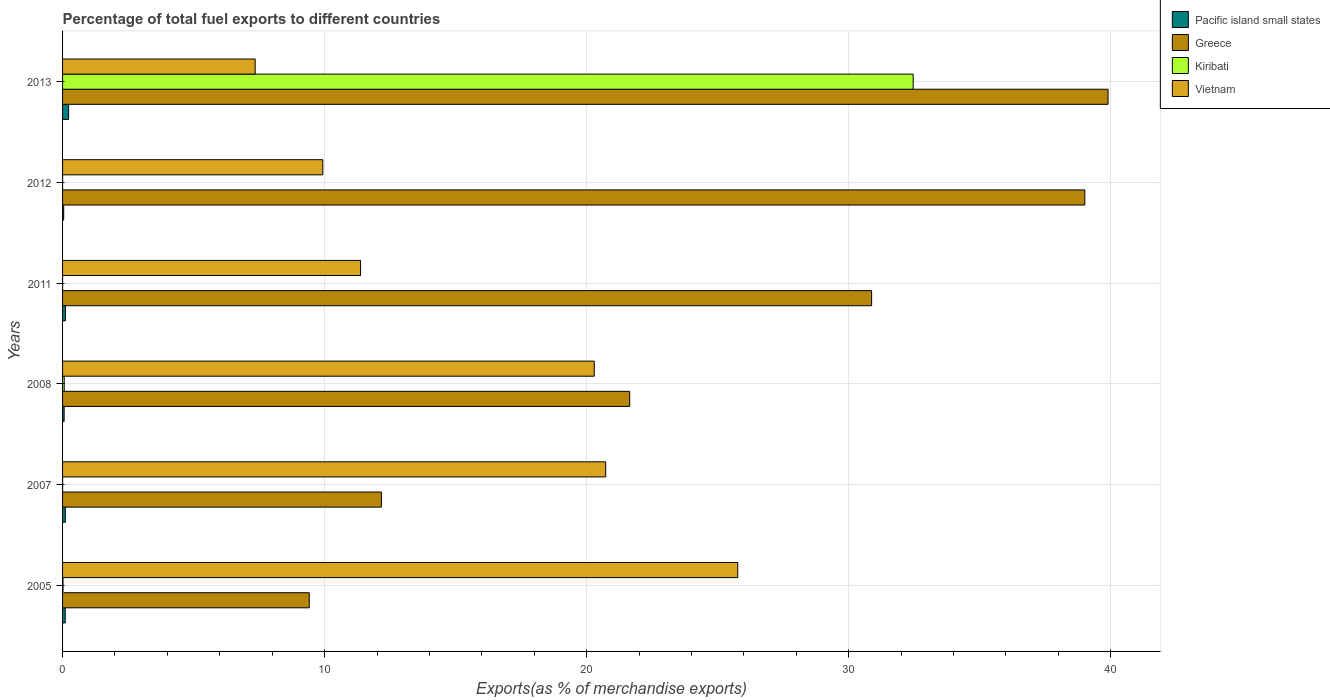Are the number of bars on each tick of the Y-axis equal?
Ensure brevity in your answer.  Yes. In how many cases, is the number of bars for a given year not equal to the number of legend labels?
Make the answer very short. 0. What is the percentage of exports to different countries in Greece in 2008?
Provide a short and direct response. 21.64. Across all years, what is the maximum percentage of exports to different countries in Vietnam?
Provide a succinct answer. 25.77. Across all years, what is the minimum percentage of exports to different countries in Kiribati?
Offer a terse response. 0. What is the total percentage of exports to different countries in Vietnam in the graph?
Provide a succinct answer. 95.43. What is the difference between the percentage of exports to different countries in Pacific island small states in 2005 and that in 2011?
Offer a very short reply. -0.01. What is the difference between the percentage of exports to different countries in Pacific island small states in 2011 and the percentage of exports to different countries in Greece in 2012?
Your answer should be very brief. -38.9. What is the average percentage of exports to different countries in Pacific island small states per year?
Keep it short and to the point. 0.11. In the year 2007, what is the difference between the percentage of exports to different countries in Greece and percentage of exports to different countries in Pacific island small states?
Keep it short and to the point. 12.06. In how many years, is the percentage of exports to different countries in Kiribati greater than 28 %?
Offer a very short reply. 1. What is the ratio of the percentage of exports to different countries in Vietnam in 2005 to that in 2011?
Your answer should be compact. 2.27. What is the difference between the highest and the second highest percentage of exports to different countries in Pacific island small states?
Your response must be concise. 0.12. What is the difference between the highest and the lowest percentage of exports to different countries in Vietnam?
Provide a short and direct response. 18.42. Is the sum of the percentage of exports to different countries in Greece in 2008 and 2013 greater than the maximum percentage of exports to different countries in Vietnam across all years?
Your answer should be very brief. Yes. What does the 4th bar from the top in 2012 represents?
Provide a short and direct response. Pacific island small states. What does the 4th bar from the bottom in 2013 represents?
Make the answer very short. Vietnam. Is it the case that in every year, the sum of the percentage of exports to different countries in Pacific island small states and percentage of exports to different countries in Vietnam is greater than the percentage of exports to different countries in Kiribati?
Ensure brevity in your answer.  No. How many bars are there?
Offer a terse response. 24. What is the difference between two consecutive major ticks on the X-axis?
Your answer should be very brief. 10. Does the graph contain any zero values?
Provide a short and direct response. No. Does the graph contain grids?
Your answer should be very brief. Yes. Where does the legend appear in the graph?
Provide a succinct answer. Top right. How many legend labels are there?
Provide a short and direct response. 4. How are the legend labels stacked?
Your response must be concise. Vertical. What is the title of the graph?
Your response must be concise. Percentage of total fuel exports to different countries. Does "Estonia" appear as one of the legend labels in the graph?
Make the answer very short. No. What is the label or title of the X-axis?
Offer a very short reply. Exports(as % of merchandise exports). What is the label or title of the Y-axis?
Offer a terse response. Years. What is the Exports(as % of merchandise exports) of Pacific island small states in 2005?
Keep it short and to the point. 0.1. What is the Exports(as % of merchandise exports) in Greece in 2005?
Provide a succinct answer. 9.41. What is the Exports(as % of merchandise exports) of Kiribati in 2005?
Your answer should be compact. 0.02. What is the Exports(as % of merchandise exports) in Vietnam in 2005?
Offer a terse response. 25.77. What is the Exports(as % of merchandise exports) of Pacific island small states in 2007?
Provide a succinct answer. 0.1. What is the Exports(as % of merchandise exports) of Greece in 2007?
Provide a succinct answer. 12.17. What is the Exports(as % of merchandise exports) in Kiribati in 2007?
Offer a terse response. 0. What is the Exports(as % of merchandise exports) in Vietnam in 2007?
Your answer should be compact. 20.73. What is the Exports(as % of merchandise exports) of Pacific island small states in 2008?
Your answer should be very brief. 0.06. What is the Exports(as % of merchandise exports) in Greece in 2008?
Provide a short and direct response. 21.64. What is the Exports(as % of merchandise exports) of Kiribati in 2008?
Your answer should be compact. 0.06. What is the Exports(as % of merchandise exports) in Vietnam in 2008?
Offer a very short reply. 20.29. What is the Exports(as % of merchandise exports) of Pacific island small states in 2011?
Make the answer very short. 0.11. What is the Exports(as % of merchandise exports) in Greece in 2011?
Provide a succinct answer. 30.87. What is the Exports(as % of merchandise exports) of Kiribati in 2011?
Keep it short and to the point. 0. What is the Exports(as % of merchandise exports) of Vietnam in 2011?
Your response must be concise. 11.37. What is the Exports(as % of merchandise exports) of Pacific island small states in 2012?
Keep it short and to the point. 0.04. What is the Exports(as % of merchandise exports) in Greece in 2012?
Offer a terse response. 39.01. What is the Exports(as % of merchandise exports) of Kiribati in 2012?
Provide a succinct answer. 0. What is the Exports(as % of merchandise exports) of Vietnam in 2012?
Provide a short and direct response. 9.93. What is the Exports(as % of merchandise exports) in Pacific island small states in 2013?
Provide a short and direct response. 0.23. What is the Exports(as % of merchandise exports) in Greece in 2013?
Keep it short and to the point. 39.9. What is the Exports(as % of merchandise exports) in Kiribati in 2013?
Ensure brevity in your answer.  32.46. What is the Exports(as % of merchandise exports) in Vietnam in 2013?
Provide a succinct answer. 7.35. Across all years, what is the maximum Exports(as % of merchandise exports) of Pacific island small states?
Make the answer very short. 0.23. Across all years, what is the maximum Exports(as % of merchandise exports) of Greece?
Provide a succinct answer. 39.9. Across all years, what is the maximum Exports(as % of merchandise exports) of Kiribati?
Make the answer very short. 32.46. Across all years, what is the maximum Exports(as % of merchandise exports) of Vietnam?
Your answer should be compact. 25.77. Across all years, what is the minimum Exports(as % of merchandise exports) of Pacific island small states?
Ensure brevity in your answer.  0.04. Across all years, what is the minimum Exports(as % of merchandise exports) in Greece?
Make the answer very short. 9.41. Across all years, what is the minimum Exports(as % of merchandise exports) in Kiribati?
Give a very brief answer. 0. Across all years, what is the minimum Exports(as % of merchandise exports) of Vietnam?
Your answer should be very brief. 7.35. What is the total Exports(as % of merchandise exports) in Pacific island small states in the graph?
Offer a very short reply. 0.65. What is the total Exports(as % of merchandise exports) in Greece in the graph?
Give a very brief answer. 153. What is the total Exports(as % of merchandise exports) in Kiribati in the graph?
Your response must be concise. 32.54. What is the total Exports(as % of merchandise exports) in Vietnam in the graph?
Offer a very short reply. 95.43. What is the difference between the Exports(as % of merchandise exports) in Pacific island small states in 2005 and that in 2007?
Make the answer very short. -0. What is the difference between the Exports(as % of merchandise exports) in Greece in 2005 and that in 2007?
Provide a succinct answer. -2.75. What is the difference between the Exports(as % of merchandise exports) in Kiribati in 2005 and that in 2007?
Your answer should be very brief. 0.02. What is the difference between the Exports(as % of merchandise exports) of Vietnam in 2005 and that in 2007?
Make the answer very short. 5.04. What is the difference between the Exports(as % of merchandise exports) of Pacific island small states in 2005 and that in 2008?
Make the answer very short. 0.04. What is the difference between the Exports(as % of merchandise exports) of Greece in 2005 and that in 2008?
Your answer should be compact. -12.23. What is the difference between the Exports(as % of merchandise exports) of Kiribati in 2005 and that in 2008?
Ensure brevity in your answer.  -0.05. What is the difference between the Exports(as % of merchandise exports) of Vietnam in 2005 and that in 2008?
Make the answer very short. 5.48. What is the difference between the Exports(as % of merchandise exports) of Pacific island small states in 2005 and that in 2011?
Give a very brief answer. -0.01. What is the difference between the Exports(as % of merchandise exports) in Greece in 2005 and that in 2011?
Keep it short and to the point. -21.46. What is the difference between the Exports(as % of merchandise exports) of Kiribati in 2005 and that in 2011?
Your answer should be very brief. 0.02. What is the difference between the Exports(as % of merchandise exports) in Vietnam in 2005 and that in 2011?
Your answer should be very brief. 14.39. What is the difference between the Exports(as % of merchandise exports) of Pacific island small states in 2005 and that in 2012?
Make the answer very short. 0.06. What is the difference between the Exports(as % of merchandise exports) in Greece in 2005 and that in 2012?
Ensure brevity in your answer.  -29.59. What is the difference between the Exports(as % of merchandise exports) in Kiribati in 2005 and that in 2012?
Make the answer very short. 0.02. What is the difference between the Exports(as % of merchandise exports) in Vietnam in 2005 and that in 2012?
Offer a very short reply. 15.84. What is the difference between the Exports(as % of merchandise exports) in Pacific island small states in 2005 and that in 2013?
Provide a short and direct response. -0.13. What is the difference between the Exports(as % of merchandise exports) of Greece in 2005 and that in 2013?
Keep it short and to the point. -30.48. What is the difference between the Exports(as % of merchandise exports) of Kiribati in 2005 and that in 2013?
Provide a short and direct response. -32.44. What is the difference between the Exports(as % of merchandise exports) in Vietnam in 2005 and that in 2013?
Keep it short and to the point. 18.42. What is the difference between the Exports(as % of merchandise exports) in Pacific island small states in 2007 and that in 2008?
Provide a succinct answer. 0.04. What is the difference between the Exports(as % of merchandise exports) in Greece in 2007 and that in 2008?
Make the answer very short. -9.47. What is the difference between the Exports(as % of merchandise exports) in Kiribati in 2007 and that in 2008?
Provide a short and direct response. -0.06. What is the difference between the Exports(as % of merchandise exports) of Vietnam in 2007 and that in 2008?
Your answer should be compact. 0.44. What is the difference between the Exports(as % of merchandise exports) in Pacific island small states in 2007 and that in 2011?
Provide a succinct answer. -0.01. What is the difference between the Exports(as % of merchandise exports) of Greece in 2007 and that in 2011?
Ensure brevity in your answer.  -18.71. What is the difference between the Exports(as % of merchandise exports) in Kiribati in 2007 and that in 2011?
Offer a terse response. 0. What is the difference between the Exports(as % of merchandise exports) in Vietnam in 2007 and that in 2011?
Provide a succinct answer. 9.35. What is the difference between the Exports(as % of merchandise exports) in Pacific island small states in 2007 and that in 2012?
Make the answer very short. 0.06. What is the difference between the Exports(as % of merchandise exports) in Greece in 2007 and that in 2012?
Offer a terse response. -26.84. What is the difference between the Exports(as % of merchandise exports) of Vietnam in 2007 and that in 2012?
Your answer should be compact. 10.8. What is the difference between the Exports(as % of merchandise exports) of Pacific island small states in 2007 and that in 2013?
Offer a very short reply. -0.13. What is the difference between the Exports(as % of merchandise exports) in Greece in 2007 and that in 2013?
Your answer should be very brief. -27.73. What is the difference between the Exports(as % of merchandise exports) in Kiribati in 2007 and that in 2013?
Give a very brief answer. -32.46. What is the difference between the Exports(as % of merchandise exports) of Vietnam in 2007 and that in 2013?
Give a very brief answer. 13.38. What is the difference between the Exports(as % of merchandise exports) in Pacific island small states in 2008 and that in 2011?
Your response must be concise. -0.05. What is the difference between the Exports(as % of merchandise exports) of Greece in 2008 and that in 2011?
Keep it short and to the point. -9.23. What is the difference between the Exports(as % of merchandise exports) of Kiribati in 2008 and that in 2011?
Your answer should be very brief. 0.06. What is the difference between the Exports(as % of merchandise exports) of Vietnam in 2008 and that in 2011?
Offer a very short reply. 8.92. What is the difference between the Exports(as % of merchandise exports) of Pacific island small states in 2008 and that in 2012?
Ensure brevity in your answer.  0.02. What is the difference between the Exports(as % of merchandise exports) of Greece in 2008 and that in 2012?
Offer a terse response. -17.37. What is the difference between the Exports(as % of merchandise exports) of Kiribati in 2008 and that in 2012?
Your response must be concise. 0.06. What is the difference between the Exports(as % of merchandise exports) in Vietnam in 2008 and that in 2012?
Your response must be concise. 10.36. What is the difference between the Exports(as % of merchandise exports) in Pacific island small states in 2008 and that in 2013?
Your answer should be very brief. -0.17. What is the difference between the Exports(as % of merchandise exports) of Greece in 2008 and that in 2013?
Provide a succinct answer. -18.25. What is the difference between the Exports(as % of merchandise exports) in Kiribati in 2008 and that in 2013?
Provide a short and direct response. -32.4. What is the difference between the Exports(as % of merchandise exports) of Vietnam in 2008 and that in 2013?
Your answer should be compact. 12.94. What is the difference between the Exports(as % of merchandise exports) in Pacific island small states in 2011 and that in 2012?
Keep it short and to the point. 0.07. What is the difference between the Exports(as % of merchandise exports) in Greece in 2011 and that in 2012?
Offer a very short reply. -8.13. What is the difference between the Exports(as % of merchandise exports) in Kiribati in 2011 and that in 2012?
Keep it short and to the point. -0. What is the difference between the Exports(as % of merchandise exports) in Vietnam in 2011 and that in 2012?
Give a very brief answer. 1.44. What is the difference between the Exports(as % of merchandise exports) of Pacific island small states in 2011 and that in 2013?
Give a very brief answer. -0.12. What is the difference between the Exports(as % of merchandise exports) of Greece in 2011 and that in 2013?
Your answer should be compact. -9.02. What is the difference between the Exports(as % of merchandise exports) in Kiribati in 2011 and that in 2013?
Offer a very short reply. -32.46. What is the difference between the Exports(as % of merchandise exports) in Vietnam in 2011 and that in 2013?
Your response must be concise. 4.02. What is the difference between the Exports(as % of merchandise exports) of Pacific island small states in 2012 and that in 2013?
Your answer should be very brief. -0.19. What is the difference between the Exports(as % of merchandise exports) in Greece in 2012 and that in 2013?
Your response must be concise. -0.89. What is the difference between the Exports(as % of merchandise exports) of Kiribati in 2012 and that in 2013?
Your response must be concise. -32.46. What is the difference between the Exports(as % of merchandise exports) of Vietnam in 2012 and that in 2013?
Make the answer very short. 2.58. What is the difference between the Exports(as % of merchandise exports) in Pacific island small states in 2005 and the Exports(as % of merchandise exports) in Greece in 2007?
Ensure brevity in your answer.  -12.06. What is the difference between the Exports(as % of merchandise exports) in Pacific island small states in 2005 and the Exports(as % of merchandise exports) in Kiribati in 2007?
Make the answer very short. 0.1. What is the difference between the Exports(as % of merchandise exports) in Pacific island small states in 2005 and the Exports(as % of merchandise exports) in Vietnam in 2007?
Ensure brevity in your answer.  -20.62. What is the difference between the Exports(as % of merchandise exports) in Greece in 2005 and the Exports(as % of merchandise exports) in Kiribati in 2007?
Ensure brevity in your answer.  9.41. What is the difference between the Exports(as % of merchandise exports) of Greece in 2005 and the Exports(as % of merchandise exports) of Vietnam in 2007?
Offer a very short reply. -11.31. What is the difference between the Exports(as % of merchandise exports) in Kiribati in 2005 and the Exports(as % of merchandise exports) in Vietnam in 2007?
Offer a very short reply. -20.71. What is the difference between the Exports(as % of merchandise exports) of Pacific island small states in 2005 and the Exports(as % of merchandise exports) of Greece in 2008?
Ensure brevity in your answer.  -21.54. What is the difference between the Exports(as % of merchandise exports) of Pacific island small states in 2005 and the Exports(as % of merchandise exports) of Kiribati in 2008?
Provide a short and direct response. 0.04. What is the difference between the Exports(as % of merchandise exports) of Pacific island small states in 2005 and the Exports(as % of merchandise exports) of Vietnam in 2008?
Provide a short and direct response. -20.19. What is the difference between the Exports(as % of merchandise exports) of Greece in 2005 and the Exports(as % of merchandise exports) of Kiribati in 2008?
Make the answer very short. 9.35. What is the difference between the Exports(as % of merchandise exports) of Greece in 2005 and the Exports(as % of merchandise exports) of Vietnam in 2008?
Make the answer very short. -10.88. What is the difference between the Exports(as % of merchandise exports) of Kiribati in 2005 and the Exports(as % of merchandise exports) of Vietnam in 2008?
Your response must be concise. -20.27. What is the difference between the Exports(as % of merchandise exports) in Pacific island small states in 2005 and the Exports(as % of merchandise exports) in Greece in 2011?
Provide a short and direct response. -30.77. What is the difference between the Exports(as % of merchandise exports) of Pacific island small states in 2005 and the Exports(as % of merchandise exports) of Kiribati in 2011?
Your response must be concise. 0.1. What is the difference between the Exports(as % of merchandise exports) in Pacific island small states in 2005 and the Exports(as % of merchandise exports) in Vietnam in 2011?
Ensure brevity in your answer.  -11.27. What is the difference between the Exports(as % of merchandise exports) of Greece in 2005 and the Exports(as % of merchandise exports) of Kiribati in 2011?
Give a very brief answer. 9.41. What is the difference between the Exports(as % of merchandise exports) in Greece in 2005 and the Exports(as % of merchandise exports) in Vietnam in 2011?
Your answer should be compact. -1.96. What is the difference between the Exports(as % of merchandise exports) of Kiribati in 2005 and the Exports(as % of merchandise exports) of Vietnam in 2011?
Your answer should be very brief. -11.36. What is the difference between the Exports(as % of merchandise exports) of Pacific island small states in 2005 and the Exports(as % of merchandise exports) of Greece in 2012?
Give a very brief answer. -38.91. What is the difference between the Exports(as % of merchandise exports) of Pacific island small states in 2005 and the Exports(as % of merchandise exports) of Kiribati in 2012?
Offer a very short reply. 0.1. What is the difference between the Exports(as % of merchandise exports) of Pacific island small states in 2005 and the Exports(as % of merchandise exports) of Vietnam in 2012?
Offer a very short reply. -9.83. What is the difference between the Exports(as % of merchandise exports) in Greece in 2005 and the Exports(as % of merchandise exports) in Kiribati in 2012?
Provide a short and direct response. 9.41. What is the difference between the Exports(as % of merchandise exports) in Greece in 2005 and the Exports(as % of merchandise exports) in Vietnam in 2012?
Make the answer very short. -0.52. What is the difference between the Exports(as % of merchandise exports) in Kiribati in 2005 and the Exports(as % of merchandise exports) in Vietnam in 2012?
Offer a terse response. -9.91. What is the difference between the Exports(as % of merchandise exports) of Pacific island small states in 2005 and the Exports(as % of merchandise exports) of Greece in 2013?
Provide a short and direct response. -39.79. What is the difference between the Exports(as % of merchandise exports) in Pacific island small states in 2005 and the Exports(as % of merchandise exports) in Kiribati in 2013?
Make the answer very short. -32.36. What is the difference between the Exports(as % of merchandise exports) in Pacific island small states in 2005 and the Exports(as % of merchandise exports) in Vietnam in 2013?
Provide a succinct answer. -7.25. What is the difference between the Exports(as % of merchandise exports) of Greece in 2005 and the Exports(as % of merchandise exports) of Kiribati in 2013?
Ensure brevity in your answer.  -23.05. What is the difference between the Exports(as % of merchandise exports) in Greece in 2005 and the Exports(as % of merchandise exports) in Vietnam in 2013?
Make the answer very short. 2.06. What is the difference between the Exports(as % of merchandise exports) in Kiribati in 2005 and the Exports(as % of merchandise exports) in Vietnam in 2013?
Your answer should be compact. -7.33. What is the difference between the Exports(as % of merchandise exports) in Pacific island small states in 2007 and the Exports(as % of merchandise exports) in Greece in 2008?
Your answer should be compact. -21.54. What is the difference between the Exports(as % of merchandise exports) in Pacific island small states in 2007 and the Exports(as % of merchandise exports) in Kiribati in 2008?
Provide a succinct answer. 0.04. What is the difference between the Exports(as % of merchandise exports) of Pacific island small states in 2007 and the Exports(as % of merchandise exports) of Vietnam in 2008?
Offer a terse response. -20.19. What is the difference between the Exports(as % of merchandise exports) of Greece in 2007 and the Exports(as % of merchandise exports) of Kiribati in 2008?
Your answer should be compact. 12.1. What is the difference between the Exports(as % of merchandise exports) in Greece in 2007 and the Exports(as % of merchandise exports) in Vietnam in 2008?
Your response must be concise. -8.12. What is the difference between the Exports(as % of merchandise exports) in Kiribati in 2007 and the Exports(as % of merchandise exports) in Vietnam in 2008?
Keep it short and to the point. -20.29. What is the difference between the Exports(as % of merchandise exports) in Pacific island small states in 2007 and the Exports(as % of merchandise exports) in Greece in 2011?
Your answer should be compact. -30.77. What is the difference between the Exports(as % of merchandise exports) in Pacific island small states in 2007 and the Exports(as % of merchandise exports) in Kiribati in 2011?
Offer a terse response. 0.1. What is the difference between the Exports(as % of merchandise exports) of Pacific island small states in 2007 and the Exports(as % of merchandise exports) of Vietnam in 2011?
Your response must be concise. -11.27. What is the difference between the Exports(as % of merchandise exports) of Greece in 2007 and the Exports(as % of merchandise exports) of Kiribati in 2011?
Provide a succinct answer. 12.17. What is the difference between the Exports(as % of merchandise exports) of Greece in 2007 and the Exports(as % of merchandise exports) of Vietnam in 2011?
Offer a very short reply. 0.8. What is the difference between the Exports(as % of merchandise exports) in Kiribati in 2007 and the Exports(as % of merchandise exports) in Vietnam in 2011?
Provide a short and direct response. -11.37. What is the difference between the Exports(as % of merchandise exports) in Pacific island small states in 2007 and the Exports(as % of merchandise exports) in Greece in 2012?
Offer a very short reply. -38.9. What is the difference between the Exports(as % of merchandise exports) of Pacific island small states in 2007 and the Exports(as % of merchandise exports) of Kiribati in 2012?
Provide a succinct answer. 0.1. What is the difference between the Exports(as % of merchandise exports) in Pacific island small states in 2007 and the Exports(as % of merchandise exports) in Vietnam in 2012?
Provide a succinct answer. -9.83. What is the difference between the Exports(as % of merchandise exports) of Greece in 2007 and the Exports(as % of merchandise exports) of Kiribati in 2012?
Your answer should be very brief. 12.17. What is the difference between the Exports(as % of merchandise exports) in Greece in 2007 and the Exports(as % of merchandise exports) in Vietnam in 2012?
Provide a succinct answer. 2.24. What is the difference between the Exports(as % of merchandise exports) in Kiribati in 2007 and the Exports(as % of merchandise exports) in Vietnam in 2012?
Ensure brevity in your answer.  -9.93. What is the difference between the Exports(as % of merchandise exports) in Pacific island small states in 2007 and the Exports(as % of merchandise exports) in Greece in 2013?
Ensure brevity in your answer.  -39.79. What is the difference between the Exports(as % of merchandise exports) in Pacific island small states in 2007 and the Exports(as % of merchandise exports) in Kiribati in 2013?
Give a very brief answer. -32.35. What is the difference between the Exports(as % of merchandise exports) in Pacific island small states in 2007 and the Exports(as % of merchandise exports) in Vietnam in 2013?
Make the answer very short. -7.25. What is the difference between the Exports(as % of merchandise exports) in Greece in 2007 and the Exports(as % of merchandise exports) in Kiribati in 2013?
Your response must be concise. -20.29. What is the difference between the Exports(as % of merchandise exports) of Greece in 2007 and the Exports(as % of merchandise exports) of Vietnam in 2013?
Provide a short and direct response. 4.82. What is the difference between the Exports(as % of merchandise exports) in Kiribati in 2007 and the Exports(as % of merchandise exports) in Vietnam in 2013?
Ensure brevity in your answer.  -7.35. What is the difference between the Exports(as % of merchandise exports) of Pacific island small states in 2008 and the Exports(as % of merchandise exports) of Greece in 2011?
Your answer should be very brief. -30.81. What is the difference between the Exports(as % of merchandise exports) in Pacific island small states in 2008 and the Exports(as % of merchandise exports) in Kiribati in 2011?
Provide a succinct answer. 0.06. What is the difference between the Exports(as % of merchandise exports) in Pacific island small states in 2008 and the Exports(as % of merchandise exports) in Vietnam in 2011?
Provide a succinct answer. -11.31. What is the difference between the Exports(as % of merchandise exports) of Greece in 2008 and the Exports(as % of merchandise exports) of Kiribati in 2011?
Keep it short and to the point. 21.64. What is the difference between the Exports(as % of merchandise exports) of Greece in 2008 and the Exports(as % of merchandise exports) of Vietnam in 2011?
Offer a very short reply. 10.27. What is the difference between the Exports(as % of merchandise exports) of Kiribati in 2008 and the Exports(as % of merchandise exports) of Vietnam in 2011?
Provide a succinct answer. -11.31. What is the difference between the Exports(as % of merchandise exports) of Pacific island small states in 2008 and the Exports(as % of merchandise exports) of Greece in 2012?
Offer a very short reply. -38.95. What is the difference between the Exports(as % of merchandise exports) in Pacific island small states in 2008 and the Exports(as % of merchandise exports) in Kiribati in 2012?
Your response must be concise. 0.06. What is the difference between the Exports(as % of merchandise exports) in Pacific island small states in 2008 and the Exports(as % of merchandise exports) in Vietnam in 2012?
Ensure brevity in your answer.  -9.87. What is the difference between the Exports(as % of merchandise exports) in Greece in 2008 and the Exports(as % of merchandise exports) in Kiribati in 2012?
Your response must be concise. 21.64. What is the difference between the Exports(as % of merchandise exports) of Greece in 2008 and the Exports(as % of merchandise exports) of Vietnam in 2012?
Offer a terse response. 11.71. What is the difference between the Exports(as % of merchandise exports) in Kiribati in 2008 and the Exports(as % of merchandise exports) in Vietnam in 2012?
Keep it short and to the point. -9.87. What is the difference between the Exports(as % of merchandise exports) of Pacific island small states in 2008 and the Exports(as % of merchandise exports) of Greece in 2013?
Provide a succinct answer. -39.84. What is the difference between the Exports(as % of merchandise exports) in Pacific island small states in 2008 and the Exports(as % of merchandise exports) in Kiribati in 2013?
Give a very brief answer. -32.4. What is the difference between the Exports(as % of merchandise exports) in Pacific island small states in 2008 and the Exports(as % of merchandise exports) in Vietnam in 2013?
Your answer should be compact. -7.29. What is the difference between the Exports(as % of merchandise exports) in Greece in 2008 and the Exports(as % of merchandise exports) in Kiribati in 2013?
Ensure brevity in your answer.  -10.82. What is the difference between the Exports(as % of merchandise exports) of Greece in 2008 and the Exports(as % of merchandise exports) of Vietnam in 2013?
Offer a very short reply. 14.29. What is the difference between the Exports(as % of merchandise exports) of Kiribati in 2008 and the Exports(as % of merchandise exports) of Vietnam in 2013?
Offer a terse response. -7.29. What is the difference between the Exports(as % of merchandise exports) of Pacific island small states in 2011 and the Exports(as % of merchandise exports) of Greece in 2012?
Make the answer very short. -38.9. What is the difference between the Exports(as % of merchandise exports) of Pacific island small states in 2011 and the Exports(as % of merchandise exports) of Kiribati in 2012?
Your response must be concise. 0.11. What is the difference between the Exports(as % of merchandise exports) in Pacific island small states in 2011 and the Exports(as % of merchandise exports) in Vietnam in 2012?
Keep it short and to the point. -9.82. What is the difference between the Exports(as % of merchandise exports) in Greece in 2011 and the Exports(as % of merchandise exports) in Kiribati in 2012?
Make the answer very short. 30.87. What is the difference between the Exports(as % of merchandise exports) in Greece in 2011 and the Exports(as % of merchandise exports) in Vietnam in 2012?
Keep it short and to the point. 20.94. What is the difference between the Exports(as % of merchandise exports) of Kiribati in 2011 and the Exports(as % of merchandise exports) of Vietnam in 2012?
Your response must be concise. -9.93. What is the difference between the Exports(as % of merchandise exports) in Pacific island small states in 2011 and the Exports(as % of merchandise exports) in Greece in 2013?
Your response must be concise. -39.79. What is the difference between the Exports(as % of merchandise exports) of Pacific island small states in 2011 and the Exports(as % of merchandise exports) of Kiribati in 2013?
Offer a terse response. -32.35. What is the difference between the Exports(as % of merchandise exports) in Pacific island small states in 2011 and the Exports(as % of merchandise exports) in Vietnam in 2013?
Offer a very short reply. -7.24. What is the difference between the Exports(as % of merchandise exports) in Greece in 2011 and the Exports(as % of merchandise exports) in Kiribati in 2013?
Offer a terse response. -1.59. What is the difference between the Exports(as % of merchandise exports) of Greece in 2011 and the Exports(as % of merchandise exports) of Vietnam in 2013?
Your answer should be very brief. 23.52. What is the difference between the Exports(as % of merchandise exports) of Kiribati in 2011 and the Exports(as % of merchandise exports) of Vietnam in 2013?
Offer a terse response. -7.35. What is the difference between the Exports(as % of merchandise exports) in Pacific island small states in 2012 and the Exports(as % of merchandise exports) in Greece in 2013?
Make the answer very short. -39.85. What is the difference between the Exports(as % of merchandise exports) of Pacific island small states in 2012 and the Exports(as % of merchandise exports) of Kiribati in 2013?
Provide a short and direct response. -32.42. What is the difference between the Exports(as % of merchandise exports) in Pacific island small states in 2012 and the Exports(as % of merchandise exports) in Vietnam in 2013?
Give a very brief answer. -7.31. What is the difference between the Exports(as % of merchandise exports) of Greece in 2012 and the Exports(as % of merchandise exports) of Kiribati in 2013?
Offer a very short reply. 6.55. What is the difference between the Exports(as % of merchandise exports) of Greece in 2012 and the Exports(as % of merchandise exports) of Vietnam in 2013?
Your answer should be compact. 31.66. What is the difference between the Exports(as % of merchandise exports) of Kiribati in 2012 and the Exports(as % of merchandise exports) of Vietnam in 2013?
Ensure brevity in your answer.  -7.35. What is the average Exports(as % of merchandise exports) in Pacific island small states per year?
Keep it short and to the point. 0.11. What is the average Exports(as % of merchandise exports) of Greece per year?
Your answer should be compact. 25.5. What is the average Exports(as % of merchandise exports) of Kiribati per year?
Provide a short and direct response. 5.42. What is the average Exports(as % of merchandise exports) in Vietnam per year?
Your response must be concise. 15.91. In the year 2005, what is the difference between the Exports(as % of merchandise exports) of Pacific island small states and Exports(as % of merchandise exports) of Greece?
Keep it short and to the point. -9.31. In the year 2005, what is the difference between the Exports(as % of merchandise exports) in Pacific island small states and Exports(as % of merchandise exports) in Kiribati?
Make the answer very short. 0.09. In the year 2005, what is the difference between the Exports(as % of merchandise exports) of Pacific island small states and Exports(as % of merchandise exports) of Vietnam?
Your response must be concise. -25.66. In the year 2005, what is the difference between the Exports(as % of merchandise exports) of Greece and Exports(as % of merchandise exports) of Kiribati?
Keep it short and to the point. 9.4. In the year 2005, what is the difference between the Exports(as % of merchandise exports) of Greece and Exports(as % of merchandise exports) of Vietnam?
Make the answer very short. -16.35. In the year 2005, what is the difference between the Exports(as % of merchandise exports) of Kiribati and Exports(as % of merchandise exports) of Vietnam?
Provide a succinct answer. -25.75. In the year 2007, what is the difference between the Exports(as % of merchandise exports) of Pacific island small states and Exports(as % of merchandise exports) of Greece?
Make the answer very short. -12.06. In the year 2007, what is the difference between the Exports(as % of merchandise exports) of Pacific island small states and Exports(as % of merchandise exports) of Kiribati?
Keep it short and to the point. 0.1. In the year 2007, what is the difference between the Exports(as % of merchandise exports) of Pacific island small states and Exports(as % of merchandise exports) of Vietnam?
Provide a short and direct response. -20.62. In the year 2007, what is the difference between the Exports(as % of merchandise exports) of Greece and Exports(as % of merchandise exports) of Kiribati?
Your response must be concise. 12.17. In the year 2007, what is the difference between the Exports(as % of merchandise exports) in Greece and Exports(as % of merchandise exports) in Vietnam?
Offer a very short reply. -8.56. In the year 2007, what is the difference between the Exports(as % of merchandise exports) in Kiribati and Exports(as % of merchandise exports) in Vietnam?
Your answer should be very brief. -20.73. In the year 2008, what is the difference between the Exports(as % of merchandise exports) of Pacific island small states and Exports(as % of merchandise exports) of Greece?
Provide a succinct answer. -21.58. In the year 2008, what is the difference between the Exports(as % of merchandise exports) in Pacific island small states and Exports(as % of merchandise exports) in Kiribati?
Offer a terse response. -0. In the year 2008, what is the difference between the Exports(as % of merchandise exports) of Pacific island small states and Exports(as % of merchandise exports) of Vietnam?
Provide a short and direct response. -20.23. In the year 2008, what is the difference between the Exports(as % of merchandise exports) of Greece and Exports(as % of merchandise exports) of Kiribati?
Your response must be concise. 21.58. In the year 2008, what is the difference between the Exports(as % of merchandise exports) in Greece and Exports(as % of merchandise exports) in Vietnam?
Give a very brief answer. 1.35. In the year 2008, what is the difference between the Exports(as % of merchandise exports) in Kiribati and Exports(as % of merchandise exports) in Vietnam?
Your answer should be very brief. -20.23. In the year 2011, what is the difference between the Exports(as % of merchandise exports) in Pacific island small states and Exports(as % of merchandise exports) in Greece?
Provide a succinct answer. -30.76. In the year 2011, what is the difference between the Exports(as % of merchandise exports) in Pacific island small states and Exports(as % of merchandise exports) in Kiribati?
Ensure brevity in your answer.  0.11. In the year 2011, what is the difference between the Exports(as % of merchandise exports) of Pacific island small states and Exports(as % of merchandise exports) of Vietnam?
Provide a succinct answer. -11.26. In the year 2011, what is the difference between the Exports(as % of merchandise exports) of Greece and Exports(as % of merchandise exports) of Kiribati?
Keep it short and to the point. 30.87. In the year 2011, what is the difference between the Exports(as % of merchandise exports) of Greece and Exports(as % of merchandise exports) of Vietnam?
Your answer should be compact. 19.5. In the year 2011, what is the difference between the Exports(as % of merchandise exports) in Kiribati and Exports(as % of merchandise exports) in Vietnam?
Ensure brevity in your answer.  -11.37. In the year 2012, what is the difference between the Exports(as % of merchandise exports) in Pacific island small states and Exports(as % of merchandise exports) in Greece?
Your response must be concise. -38.96. In the year 2012, what is the difference between the Exports(as % of merchandise exports) in Pacific island small states and Exports(as % of merchandise exports) in Kiribati?
Provide a short and direct response. 0.04. In the year 2012, what is the difference between the Exports(as % of merchandise exports) of Pacific island small states and Exports(as % of merchandise exports) of Vietnam?
Your answer should be compact. -9.89. In the year 2012, what is the difference between the Exports(as % of merchandise exports) in Greece and Exports(as % of merchandise exports) in Kiribati?
Provide a succinct answer. 39.01. In the year 2012, what is the difference between the Exports(as % of merchandise exports) in Greece and Exports(as % of merchandise exports) in Vietnam?
Your answer should be very brief. 29.08. In the year 2012, what is the difference between the Exports(as % of merchandise exports) in Kiribati and Exports(as % of merchandise exports) in Vietnam?
Your response must be concise. -9.93. In the year 2013, what is the difference between the Exports(as % of merchandise exports) in Pacific island small states and Exports(as % of merchandise exports) in Greece?
Your answer should be very brief. -39.67. In the year 2013, what is the difference between the Exports(as % of merchandise exports) in Pacific island small states and Exports(as % of merchandise exports) in Kiribati?
Keep it short and to the point. -32.23. In the year 2013, what is the difference between the Exports(as % of merchandise exports) in Pacific island small states and Exports(as % of merchandise exports) in Vietnam?
Keep it short and to the point. -7.12. In the year 2013, what is the difference between the Exports(as % of merchandise exports) of Greece and Exports(as % of merchandise exports) of Kiribati?
Ensure brevity in your answer.  7.44. In the year 2013, what is the difference between the Exports(as % of merchandise exports) of Greece and Exports(as % of merchandise exports) of Vietnam?
Offer a terse response. 32.55. In the year 2013, what is the difference between the Exports(as % of merchandise exports) of Kiribati and Exports(as % of merchandise exports) of Vietnam?
Your answer should be very brief. 25.11. What is the ratio of the Exports(as % of merchandise exports) of Pacific island small states in 2005 to that in 2007?
Keep it short and to the point. 0.99. What is the ratio of the Exports(as % of merchandise exports) in Greece in 2005 to that in 2007?
Give a very brief answer. 0.77. What is the ratio of the Exports(as % of merchandise exports) of Kiribati in 2005 to that in 2007?
Make the answer very short. 69.38. What is the ratio of the Exports(as % of merchandise exports) of Vietnam in 2005 to that in 2007?
Provide a short and direct response. 1.24. What is the ratio of the Exports(as % of merchandise exports) in Pacific island small states in 2005 to that in 2008?
Give a very brief answer. 1.7. What is the ratio of the Exports(as % of merchandise exports) in Greece in 2005 to that in 2008?
Your response must be concise. 0.43. What is the ratio of the Exports(as % of merchandise exports) in Kiribati in 2005 to that in 2008?
Keep it short and to the point. 0.27. What is the ratio of the Exports(as % of merchandise exports) of Vietnam in 2005 to that in 2008?
Provide a short and direct response. 1.27. What is the ratio of the Exports(as % of merchandise exports) in Pacific island small states in 2005 to that in 2011?
Give a very brief answer. 0.93. What is the ratio of the Exports(as % of merchandise exports) of Greece in 2005 to that in 2011?
Give a very brief answer. 0.3. What is the ratio of the Exports(as % of merchandise exports) of Kiribati in 2005 to that in 2011?
Your response must be concise. 147.01. What is the ratio of the Exports(as % of merchandise exports) of Vietnam in 2005 to that in 2011?
Your answer should be compact. 2.27. What is the ratio of the Exports(as % of merchandise exports) of Pacific island small states in 2005 to that in 2012?
Ensure brevity in your answer.  2.39. What is the ratio of the Exports(as % of merchandise exports) of Greece in 2005 to that in 2012?
Keep it short and to the point. 0.24. What is the ratio of the Exports(as % of merchandise exports) in Kiribati in 2005 to that in 2012?
Your answer should be compact. 99.44. What is the ratio of the Exports(as % of merchandise exports) of Vietnam in 2005 to that in 2012?
Provide a succinct answer. 2.59. What is the ratio of the Exports(as % of merchandise exports) of Pacific island small states in 2005 to that in 2013?
Make the answer very short. 0.44. What is the ratio of the Exports(as % of merchandise exports) in Greece in 2005 to that in 2013?
Keep it short and to the point. 0.24. What is the ratio of the Exports(as % of merchandise exports) in Vietnam in 2005 to that in 2013?
Ensure brevity in your answer.  3.51. What is the ratio of the Exports(as % of merchandise exports) of Pacific island small states in 2007 to that in 2008?
Your answer should be compact. 1.72. What is the ratio of the Exports(as % of merchandise exports) of Greece in 2007 to that in 2008?
Provide a succinct answer. 0.56. What is the ratio of the Exports(as % of merchandise exports) of Kiribati in 2007 to that in 2008?
Offer a very short reply. 0. What is the ratio of the Exports(as % of merchandise exports) in Vietnam in 2007 to that in 2008?
Your answer should be very brief. 1.02. What is the ratio of the Exports(as % of merchandise exports) in Pacific island small states in 2007 to that in 2011?
Make the answer very short. 0.94. What is the ratio of the Exports(as % of merchandise exports) of Greece in 2007 to that in 2011?
Offer a terse response. 0.39. What is the ratio of the Exports(as % of merchandise exports) of Kiribati in 2007 to that in 2011?
Ensure brevity in your answer.  2.12. What is the ratio of the Exports(as % of merchandise exports) in Vietnam in 2007 to that in 2011?
Make the answer very short. 1.82. What is the ratio of the Exports(as % of merchandise exports) of Pacific island small states in 2007 to that in 2012?
Your answer should be compact. 2.43. What is the ratio of the Exports(as % of merchandise exports) in Greece in 2007 to that in 2012?
Make the answer very short. 0.31. What is the ratio of the Exports(as % of merchandise exports) in Kiribati in 2007 to that in 2012?
Offer a very short reply. 1.43. What is the ratio of the Exports(as % of merchandise exports) in Vietnam in 2007 to that in 2012?
Your answer should be compact. 2.09. What is the ratio of the Exports(as % of merchandise exports) of Pacific island small states in 2007 to that in 2013?
Provide a succinct answer. 0.45. What is the ratio of the Exports(as % of merchandise exports) in Greece in 2007 to that in 2013?
Your response must be concise. 0.3. What is the ratio of the Exports(as % of merchandise exports) of Vietnam in 2007 to that in 2013?
Your answer should be very brief. 2.82. What is the ratio of the Exports(as % of merchandise exports) of Pacific island small states in 2008 to that in 2011?
Your answer should be very brief. 0.55. What is the ratio of the Exports(as % of merchandise exports) of Greece in 2008 to that in 2011?
Make the answer very short. 0.7. What is the ratio of the Exports(as % of merchandise exports) of Kiribati in 2008 to that in 2011?
Give a very brief answer. 540.83. What is the ratio of the Exports(as % of merchandise exports) of Vietnam in 2008 to that in 2011?
Your answer should be compact. 1.78. What is the ratio of the Exports(as % of merchandise exports) of Pacific island small states in 2008 to that in 2012?
Provide a succinct answer. 1.41. What is the ratio of the Exports(as % of merchandise exports) of Greece in 2008 to that in 2012?
Keep it short and to the point. 0.55. What is the ratio of the Exports(as % of merchandise exports) of Kiribati in 2008 to that in 2012?
Provide a succinct answer. 365.82. What is the ratio of the Exports(as % of merchandise exports) of Vietnam in 2008 to that in 2012?
Your answer should be compact. 2.04. What is the ratio of the Exports(as % of merchandise exports) of Pacific island small states in 2008 to that in 2013?
Keep it short and to the point. 0.26. What is the ratio of the Exports(as % of merchandise exports) in Greece in 2008 to that in 2013?
Offer a terse response. 0.54. What is the ratio of the Exports(as % of merchandise exports) in Kiribati in 2008 to that in 2013?
Make the answer very short. 0. What is the ratio of the Exports(as % of merchandise exports) in Vietnam in 2008 to that in 2013?
Offer a terse response. 2.76. What is the ratio of the Exports(as % of merchandise exports) in Pacific island small states in 2011 to that in 2012?
Your answer should be very brief. 2.58. What is the ratio of the Exports(as % of merchandise exports) of Greece in 2011 to that in 2012?
Make the answer very short. 0.79. What is the ratio of the Exports(as % of merchandise exports) of Kiribati in 2011 to that in 2012?
Offer a very short reply. 0.68. What is the ratio of the Exports(as % of merchandise exports) of Vietnam in 2011 to that in 2012?
Ensure brevity in your answer.  1.15. What is the ratio of the Exports(as % of merchandise exports) in Pacific island small states in 2011 to that in 2013?
Your answer should be very brief. 0.48. What is the ratio of the Exports(as % of merchandise exports) of Greece in 2011 to that in 2013?
Give a very brief answer. 0.77. What is the ratio of the Exports(as % of merchandise exports) in Vietnam in 2011 to that in 2013?
Keep it short and to the point. 1.55. What is the ratio of the Exports(as % of merchandise exports) of Pacific island small states in 2012 to that in 2013?
Your response must be concise. 0.19. What is the ratio of the Exports(as % of merchandise exports) in Greece in 2012 to that in 2013?
Offer a terse response. 0.98. What is the ratio of the Exports(as % of merchandise exports) of Vietnam in 2012 to that in 2013?
Provide a short and direct response. 1.35. What is the difference between the highest and the second highest Exports(as % of merchandise exports) in Pacific island small states?
Offer a terse response. 0.12. What is the difference between the highest and the second highest Exports(as % of merchandise exports) in Greece?
Provide a short and direct response. 0.89. What is the difference between the highest and the second highest Exports(as % of merchandise exports) in Kiribati?
Offer a terse response. 32.4. What is the difference between the highest and the second highest Exports(as % of merchandise exports) in Vietnam?
Give a very brief answer. 5.04. What is the difference between the highest and the lowest Exports(as % of merchandise exports) in Pacific island small states?
Ensure brevity in your answer.  0.19. What is the difference between the highest and the lowest Exports(as % of merchandise exports) in Greece?
Keep it short and to the point. 30.48. What is the difference between the highest and the lowest Exports(as % of merchandise exports) of Kiribati?
Your answer should be compact. 32.46. What is the difference between the highest and the lowest Exports(as % of merchandise exports) of Vietnam?
Offer a very short reply. 18.42. 